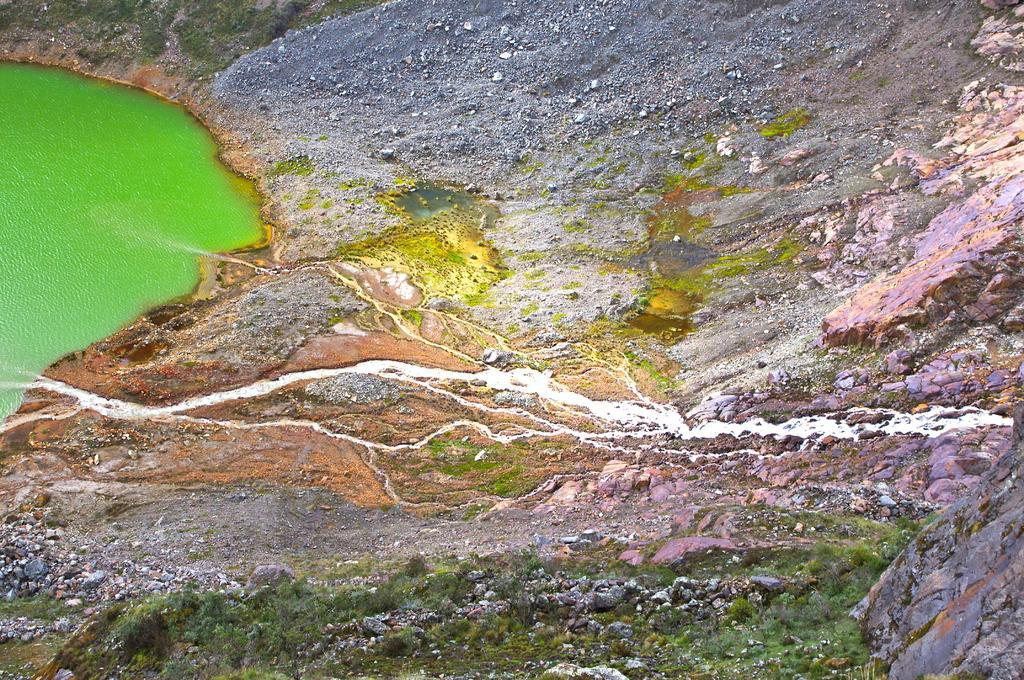Can you describe this image briefly? In this image we can see the water. There are few rocks in the image. 